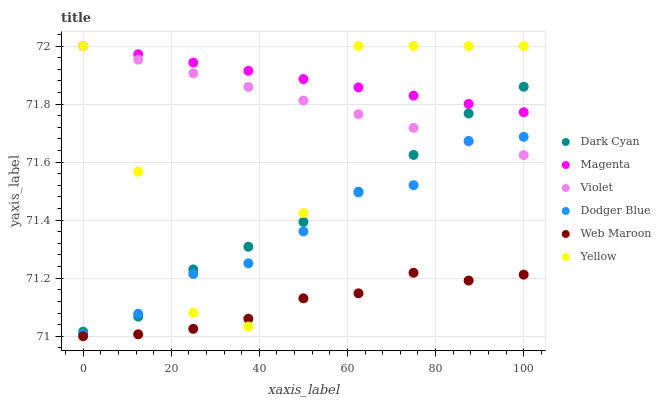Does Web Maroon have the minimum area under the curve?
Answer yes or no. Yes. Does Magenta have the maximum area under the curve?
Answer yes or no. Yes. Does Yellow have the minimum area under the curve?
Answer yes or no. No. Does Yellow have the maximum area under the curve?
Answer yes or no. No. Is Magenta the smoothest?
Answer yes or no. Yes. Is Yellow the roughest?
Answer yes or no. Yes. Is Dodger Blue the smoothest?
Answer yes or no. No. Is Dodger Blue the roughest?
Answer yes or no. No. Does Web Maroon have the lowest value?
Answer yes or no. Yes. Does Yellow have the lowest value?
Answer yes or no. No. Does Magenta have the highest value?
Answer yes or no. Yes. Does Dodger Blue have the highest value?
Answer yes or no. No. Is Dodger Blue less than Magenta?
Answer yes or no. Yes. Is Magenta greater than Dodger Blue?
Answer yes or no. Yes. Does Yellow intersect Violet?
Answer yes or no. Yes. Is Yellow less than Violet?
Answer yes or no. No. Is Yellow greater than Violet?
Answer yes or no. No. Does Dodger Blue intersect Magenta?
Answer yes or no. No. 